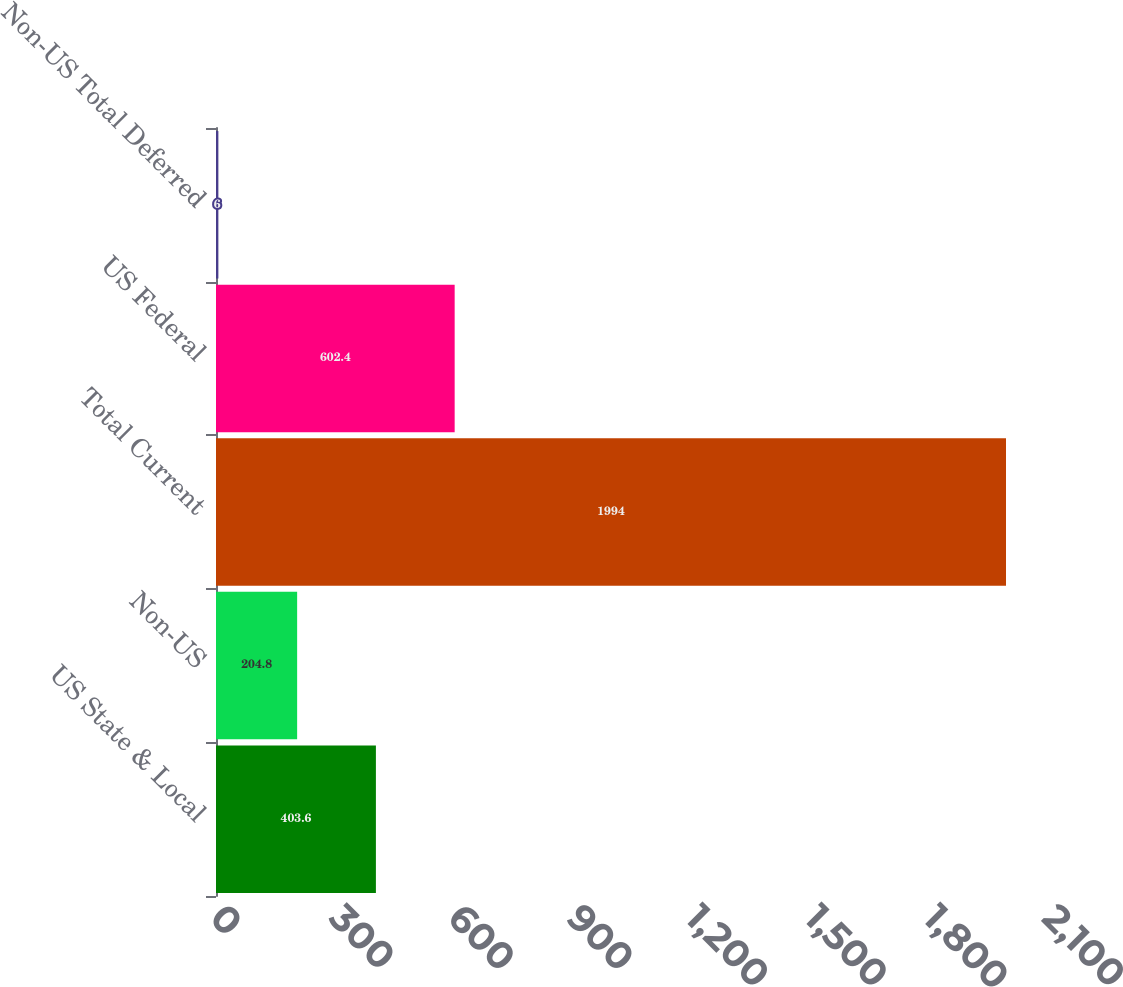<chart> <loc_0><loc_0><loc_500><loc_500><bar_chart><fcel>US State & Local<fcel>Non-US<fcel>Total Current<fcel>US Federal<fcel>Non-US Total Deferred<nl><fcel>403.6<fcel>204.8<fcel>1994<fcel>602.4<fcel>6<nl></chart> 